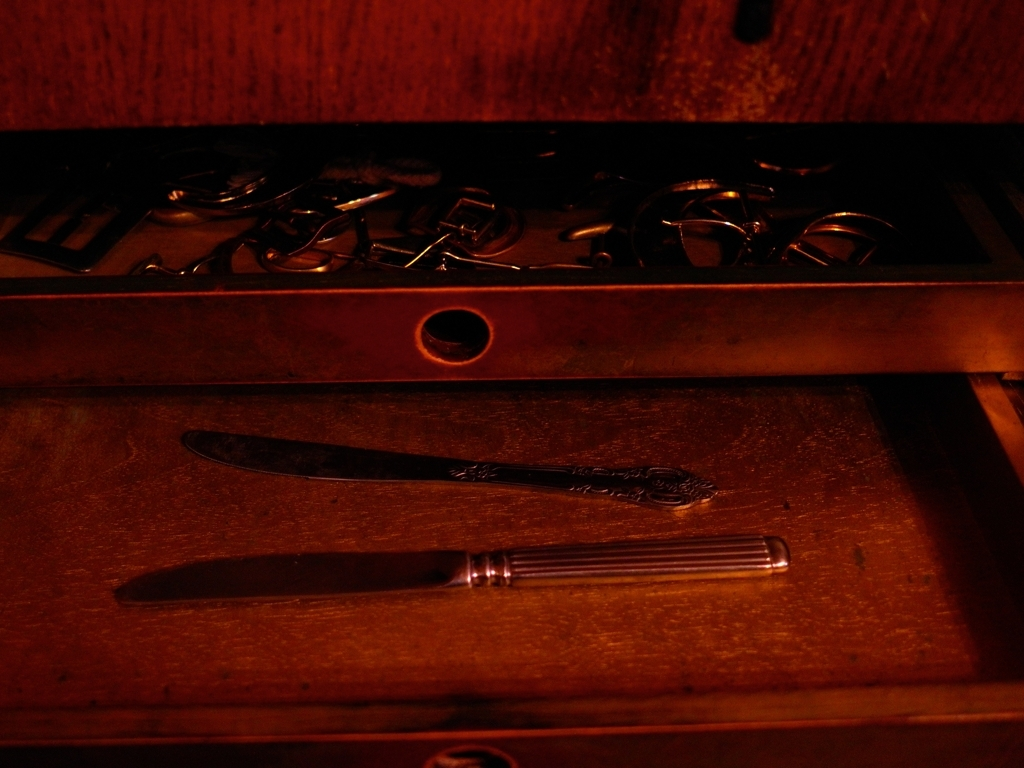Could you describe the mood or atmosphere the image evokes, and why? The image emanates a moody and mysterious atmosphere, primarily due to the dim lighting and shadow play. The warm, subdued color palette and the unfinished wood surface add a sense of age and nostalgia, potentially evoking feelings of reflecting on the past or uncovering forgotten memories. 